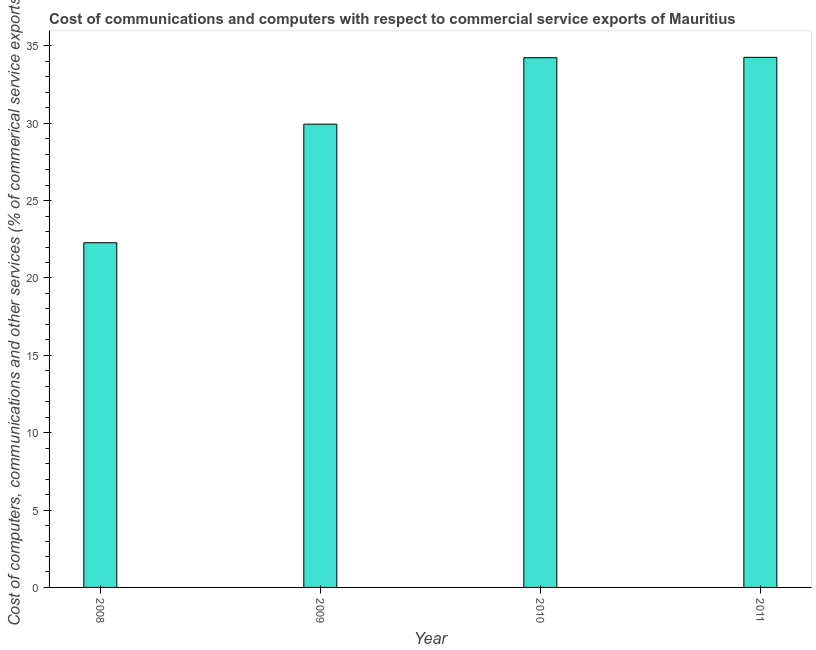Does the graph contain any zero values?
Offer a terse response. No. What is the title of the graph?
Ensure brevity in your answer.  Cost of communications and computers with respect to commercial service exports of Mauritius. What is the label or title of the X-axis?
Keep it short and to the point. Year. What is the label or title of the Y-axis?
Offer a very short reply. Cost of computers, communications and other services (% of commerical service exports). What is the cost of communications in 2009?
Make the answer very short. 29.94. Across all years, what is the maximum cost of communications?
Keep it short and to the point. 34.26. Across all years, what is the minimum  computer and other services?
Provide a succinct answer. 22.28. In which year was the  computer and other services maximum?
Ensure brevity in your answer.  2011. What is the sum of the  computer and other services?
Provide a short and direct response. 120.71. What is the difference between the  computer and other services in 2008 and 2010?
Keep it short and to the point. -11.96. What is the average cost of communications per year?
Offer a terse response. 30.18. What is the median cost of communications?
Provide a short and direct response. 32.09. In how many years, is the  computer and other services greater than 24 %?
Offer a terse response. 3. Do a majority of the years between 2011 and 2010 (inclusive) have cost of communications greater than 33 %?
Your answer should be compact. No. What is the ratio of the cost of communications in 2009 to that in 2011?
Keep it short and to the point. 0.87. Is the  computer and other services in 2010 less than that in 2011?
Ensure brevity in your answer.  Yes. Is the difference between the  computer and other services in 2010 and 2011 greater than the difference between any two years?
Your response must be concise. No. What is the difference between the highest and the second highest  computer and other services?
Your answer should be compact. 0.02. Is the sum of the  computer and other services in 2009 and 2010 greater than the maximum  computer and other services across all years?
Make the answer very short. Yes. What is the difference between the highest and the lowest  computer and other services?
Your answer should be compact. 11.98. In how many years, is the  computer and other services greater than the average  computer and other services taken over all years?
Provide a succinct answer. 2. How many bars are there?
Your response must be concise. 4. How many years are there in the graph?
Offer a very short reply. 4. What is the difference between two consecutive major ticks on the Y-axis?
Your response must be concise. 5. Are the values on the major ticks of Y-axis written in scientific E-notation?
Your answer should be very brief. No. What is the Cost of computers, communications and other services (% of commerical service exports) in 2008?
Keep it short and to the point. 22.28. What is the Cost of computers, communications and other services (% of commerical service exports) of 2009?
Ensure brevity in your answer.  29.94. What is the Cost of computers, communications and other services (% of commerical service exports) in 2010?
Provide a succinct answer. 34.24. What is the Cost of computers, communications and other services (% of commerical service exports) of 2011?
Offer a terse response. 34.26. What is the difference between the Cost of computers, communications and other services (% of commerical service exports) in 2008 and 2009?
Give a very brief answer. -7.66. What is the difference between the Cost of computers, communications and other services (% of commerical service exports) in 2008 and 2010?
Your answer should be compact. -11.96. What is the difference between the Cost of computers, communications and other services (% of commerical service exports) in 2008 and 2011?
Ensure brevity in your answer.  -11.98. What is the difference between the Cost of computers, communications and other services (% of commerical service exports) in 2009 and 2010?
Provide a short and direct response. -4.3. What is the difference between the Cost of computers, communications and other services (% of commerical service exports) in 2009 and 2011?
Your answer should be compact. -4.32. What is the difference between the Cost of computers, communications and other services (% of commerical service exports) in 2010 and 2011?
Keep it short and to the point. -0.02. What is the ratio of the Cost of computers, communications and other services (% of commerical service exports) in 2008 to that in 2009?
Your answer should be very brief. 0.74. What is the ratio of the Cost of computers, communications and other services (% of commerical service exports) in 2008 to that in 2010?
Offer a very short reply. 0.65. What is the ratio of the Cost of computers, communications and other services (% of commerical service exports) in 2008 to that in 2011?
Offer a terse response. 0.65. What is the ratio of the Cost of computers, communications and other services (% of commerical service exports) in 2009 to that in 2010?
Your response must be concise. 0.88. What is the ratio of the Cost of computers, communications and other services (% of commerical service exports) in 2009 to that in 2011?
Make the answer very short. 0.87. What is the ratio of the Cost of computers, communications and other services (% of commerical service exports) in 2010 to that in 2011?
Keep it short and to the point. 1. 